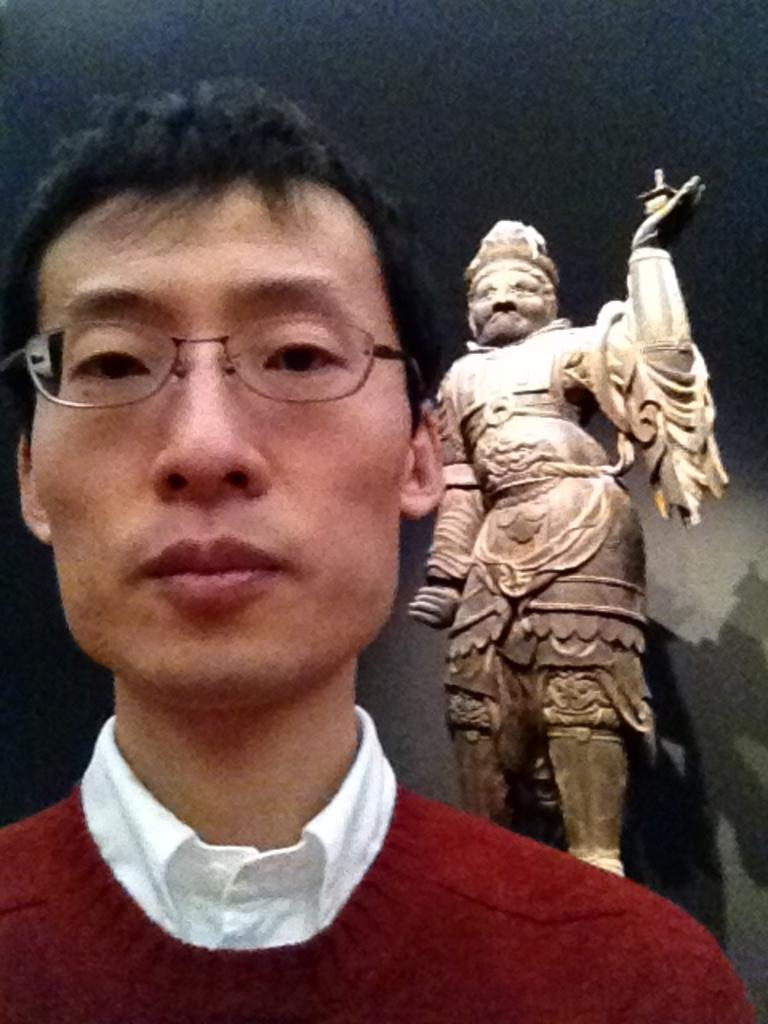Who is present in the image? There is a man in the image. What is the man wearing? The man is wearing a red shirt. What can be seen on the right side of the image? There is a sculpture on the right side of the image. How many oranges are being used for the magic trick in the image? There are no oranges or magic tricks present in the image. What type of boats can be seen in the harbor in the image? There is no harbor or boats present in the image. 